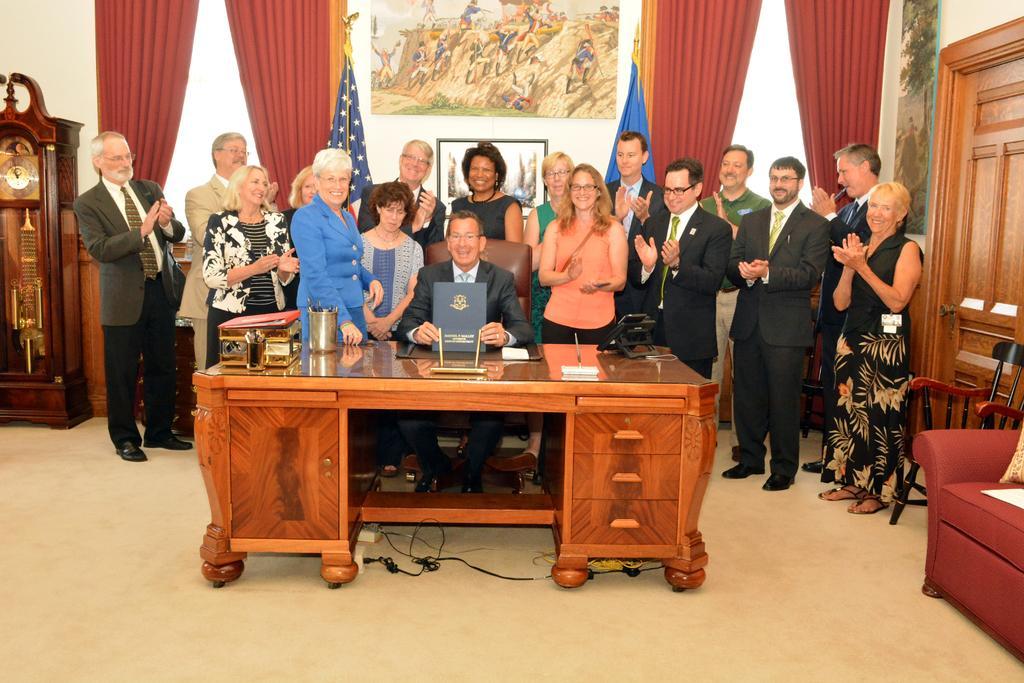Please provide a concise description of this image. In the image there are old men and women in suits clapping standing behind a table, behind them there are curtains on the wall with paintings in the middle, on the right side there is sofa and chair, on the left side there is a clock in front of the wall. 